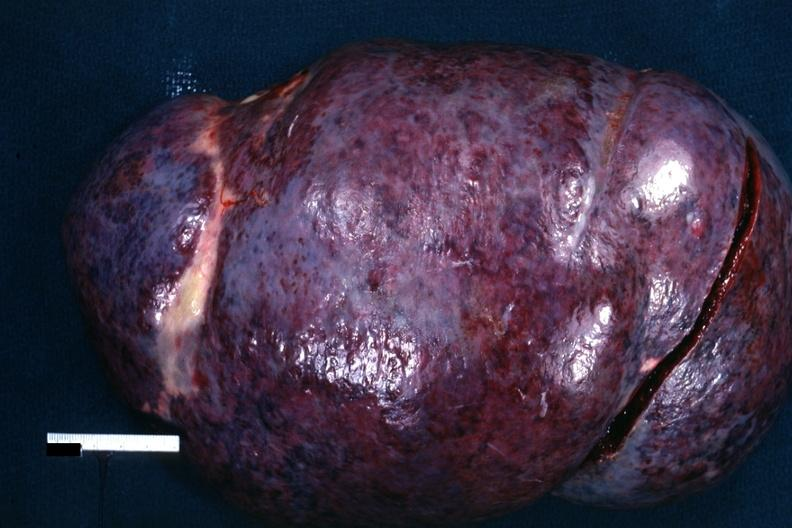s hematologic present?
Answer the question using a single word or phrase. Yes 